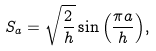<formula> <loc_0><loc_0><loc_500><loc_500>S _ { a } = \sqrt { \frac { 2 } { h } } \sin { \left ( \frac { \pi a } { h } \right ) } ,</formula> 